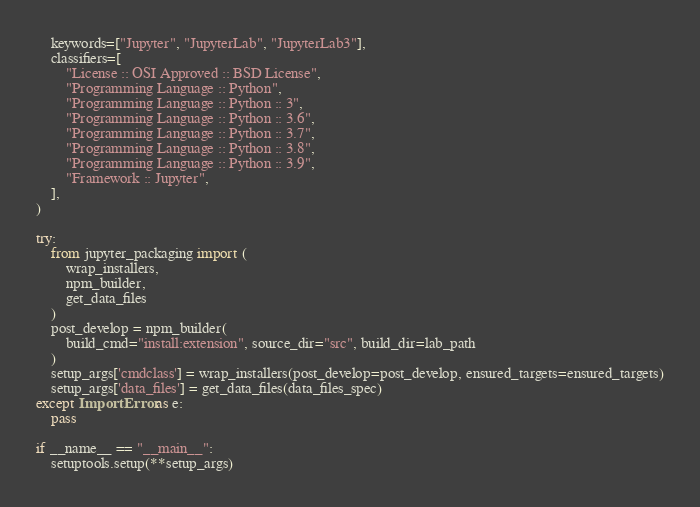<code> <loc_0><loc_0><loc_500><loc_500><_Python_>    keywords=["Jupyter", "JupyterLab", "JupyterLab3"],
    classifiers=[
        "License :: OSI Approved :: BSD License",
        "Programming Language :: Python",
        "Programming Language :: Python :: 3",
        "Programming Language :: Python :: 3.6",
        "Programming Language :: Python :: 3.7",
        "Programming Language :: Python :: 3.8",
        "Programming Language :: Python :: 3.9",
        "Framework :: Jupyter",
    ],
)

try:
    from jupyter_packaging import (
        wrap_installers,
        npm_builder,
        get_data_files
    )
    post_develop = npm_builder(
        build_cmd="install:extension", source_dir="src", build_dir=lab_path
    )
    setup_args['cmdclass'] = wrap_installers(post_develop=post_develop, ensured_targets=ensured_targets)
    setup_args['data_files'] = get_data_files(data_files_spec)
except ImportError as e:
    pass

if __name__ == "__main__":
    setuptools.setup(**setup_args)
</code> 